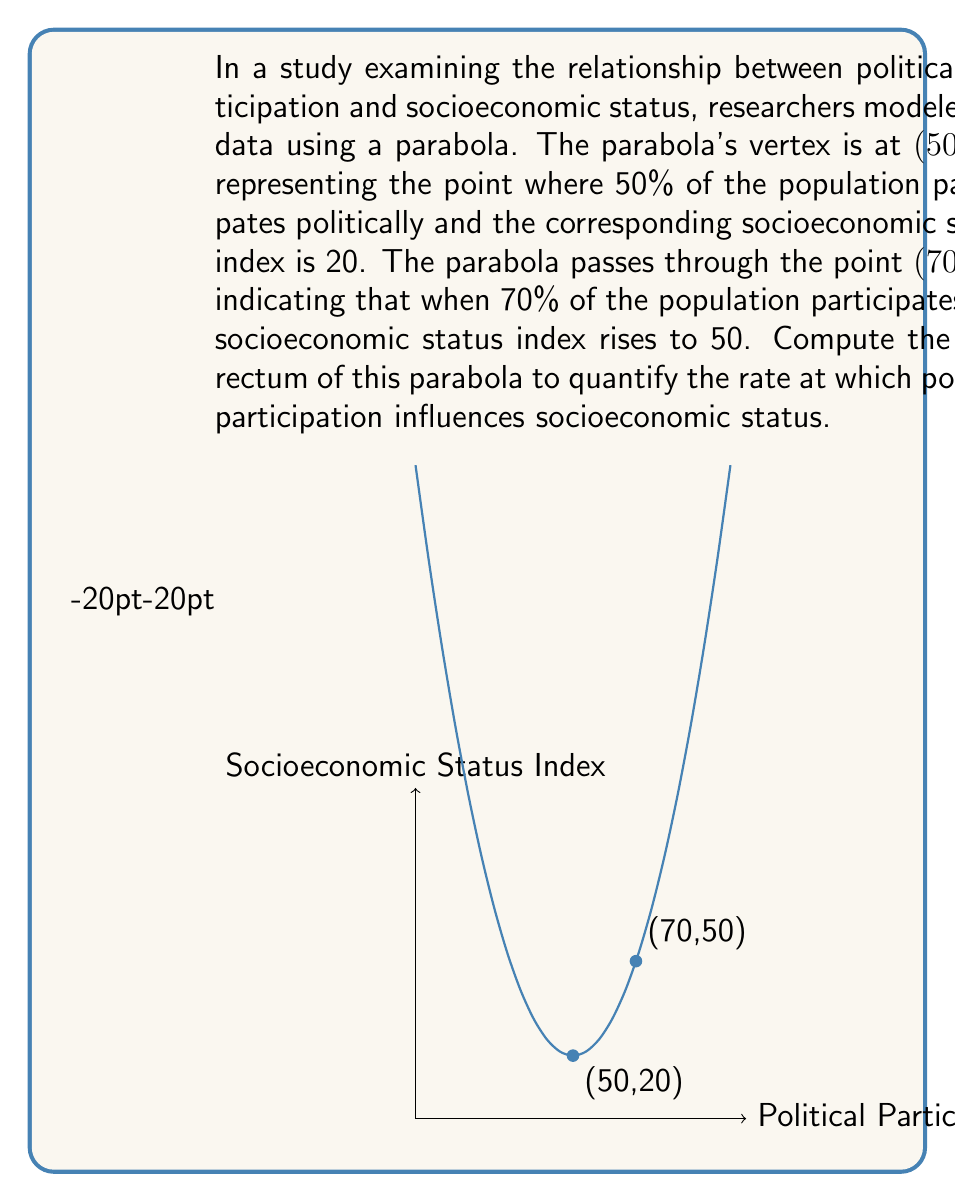Help me with this question. Let's approach this step-by-step:

1) The general form of a parabola with vertex $(h,k)$ is:
   $y = a(x-h)^2 + k$

2) We know the vertex is (50, 20), so $h=50$ and $k=20$. Our equation becomes:
   $y = a(x-50)^2 + 20$

3) We can find $a$ using the point (70, 50):
   $50 = a(70-50)^2 + 20$
   $30 = a(20)^2$
   $30 = 400a$
   $a = \frac{30}{400} = 0.075$

4) So our parabola equation is:
   $y = 0.075(x-50)^2 + 20$

5) The latus rectum of a parabola is the line segment that passes through the focus, is parallel to the directrix, and has endpoints on the parabola. Its length is given by $\frac{4}{|a|}$ where $a$ is the coefficient of $(x-h)^2$ in the equation $y = a(x-h)^2 + k$.

6) In this case, $a = 0.075$, so the length of the latus rectum is:
   $\text{Latus Rectum} = \frac{4}{|0.075|} = \frac{4}{0.075} \approx 53.33$

This value quantifies how quickly the socioeconomic status index changes with political participation. A larger latus rectum indicates a slower rate of change, while a smaller one suggests a more rapid influence of political participation on socioeconomic status.
Answer: $\frac{4}{0.075} \approx 53.33$ 